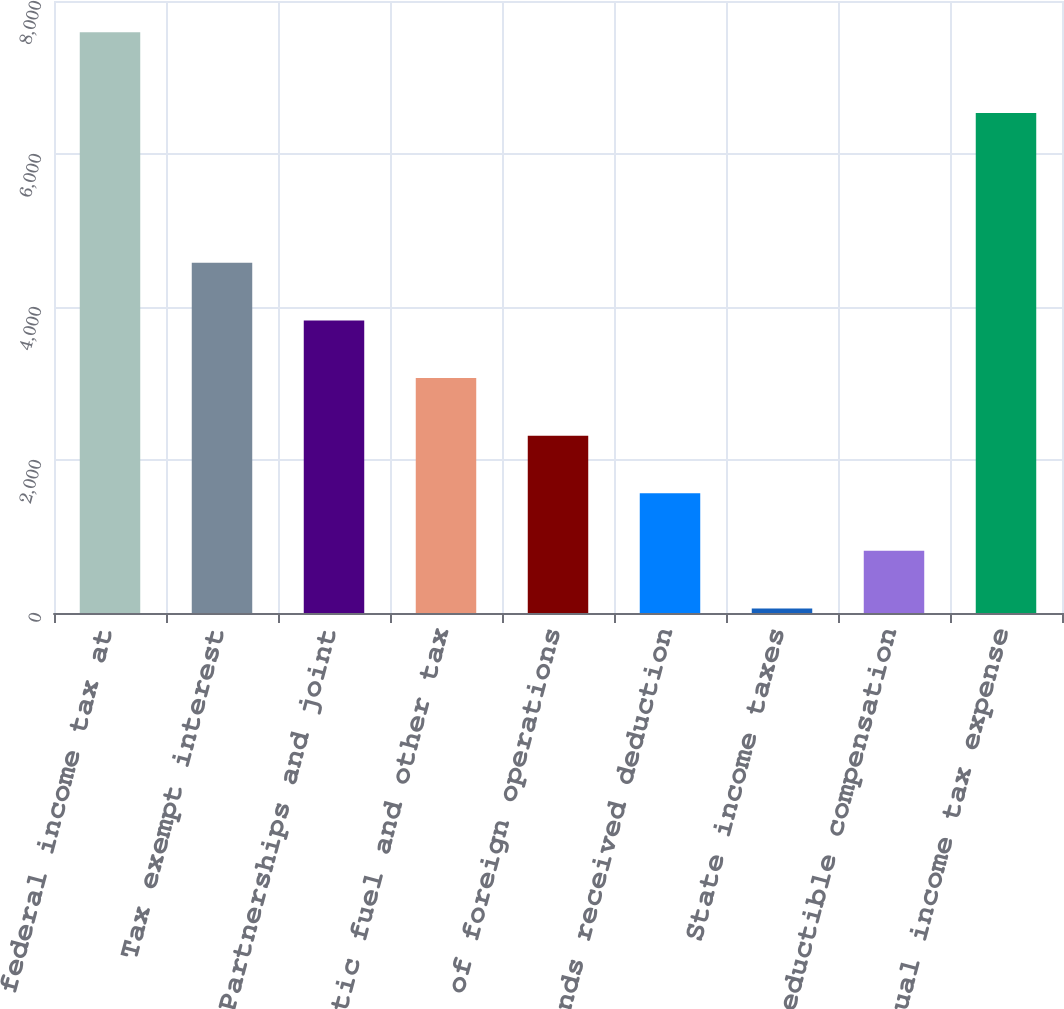Convert chart. <chart><loc_0><loc_0><loc_500><loc_500><bar_chart><fcel>US federal income tax at<fcel>Tax exempt interest<fcel>Partnerships and joint<fcel>Synthetic fuel and other tax<fcel>Effect of foreign operations<fcel>Dividends received deduction<fcel>State income taxes<fcel>Nondeductible compensation<fcel>Actual income tax expense<nl><fcel>7591<fcel>4578.2<fcel>3825<fcel>3071.8<fcel>2318.6<fcel>1565.4<fcel>59<fcel>812.2<fcel>6537<nl></chart> 